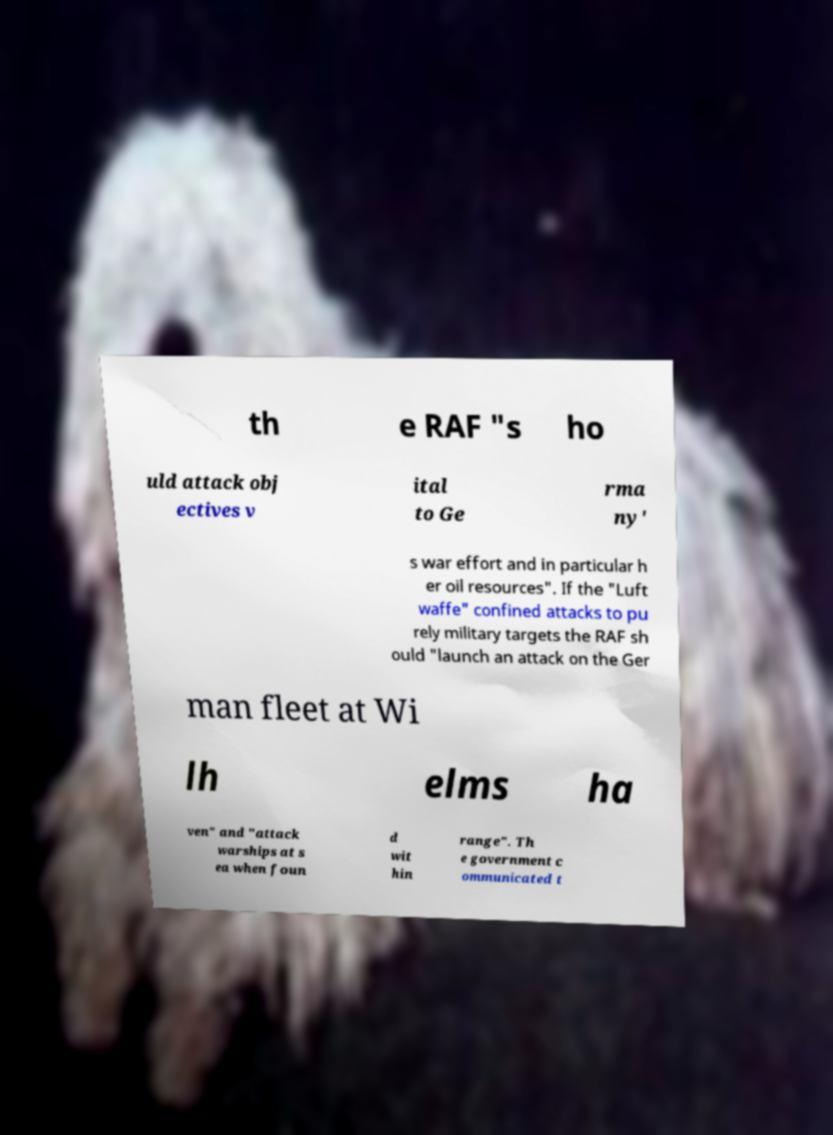Can you accurately transcribe the text from the provided image for me? th e RAF "s ho uld attack obj ectives v ital to Ge rma ny' s war effort and in particular h er oil resources". If the "Luft waffe" confined attacks to pu rely military targets the RAF sh ould "launch an attack on the Ger man fleet at Wi lh elms ha ven" and "attack warships at s ea when foun d wit hin range". Th e government c ommunicated t 